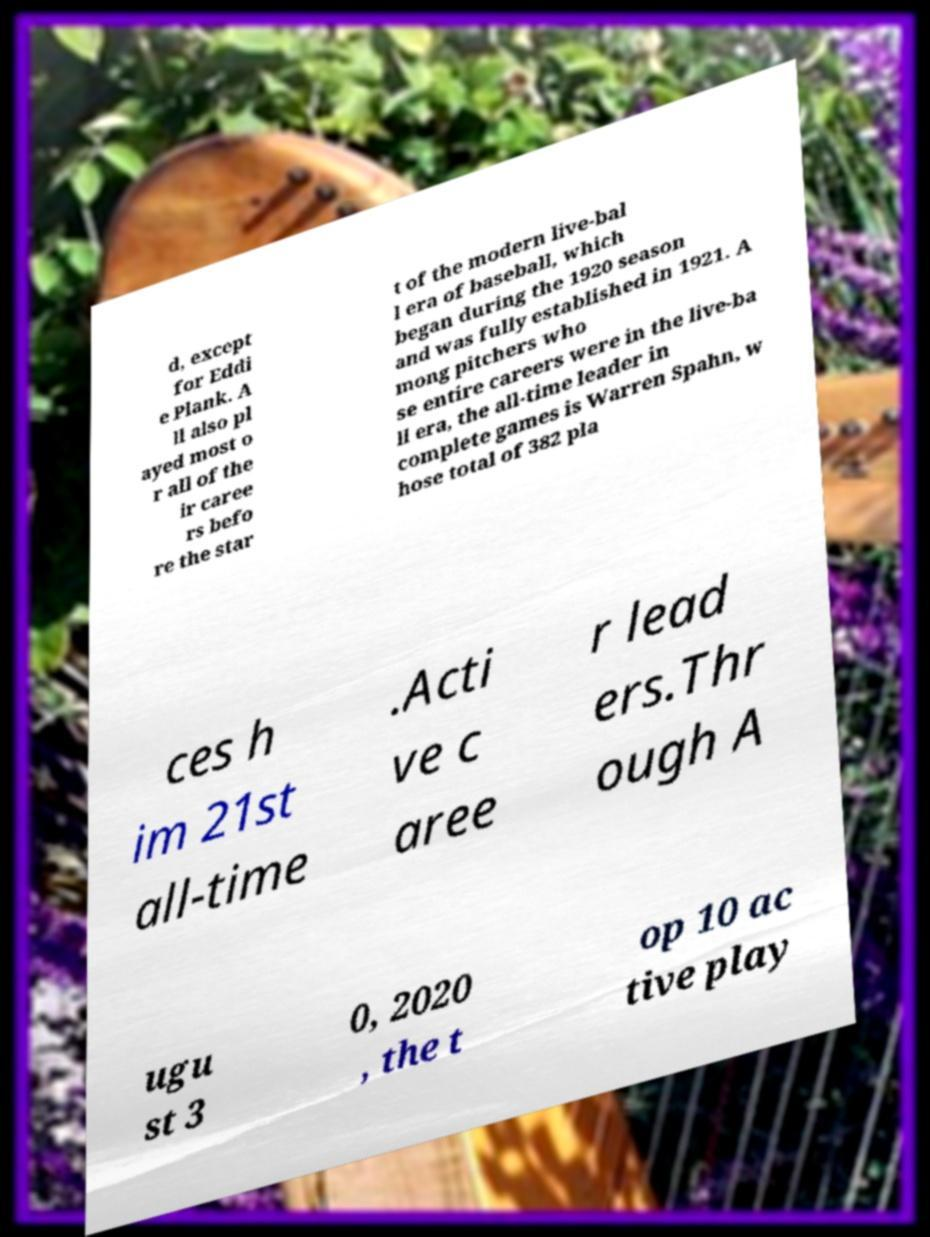There's text embedded in this image that I need extracted. Can you transcribe it verbatim? d, except for Eddi e Plank. A ll also pl ayed most o r all of the ir caree rs befo re the star t of the modern live-bal l era of baseball, which began during the 1920 season and was fully established in 1921. A mong pitchers who se entire careers were in the live-ba ll era, the all-time leader in complete games is Warren Spahn, w hose total of 382 pla ces h im 21st all-time .Acti ve c aree r lead ers.Thr ough A ugu st 3 0, 2020 , the t op 10 ac tive play 